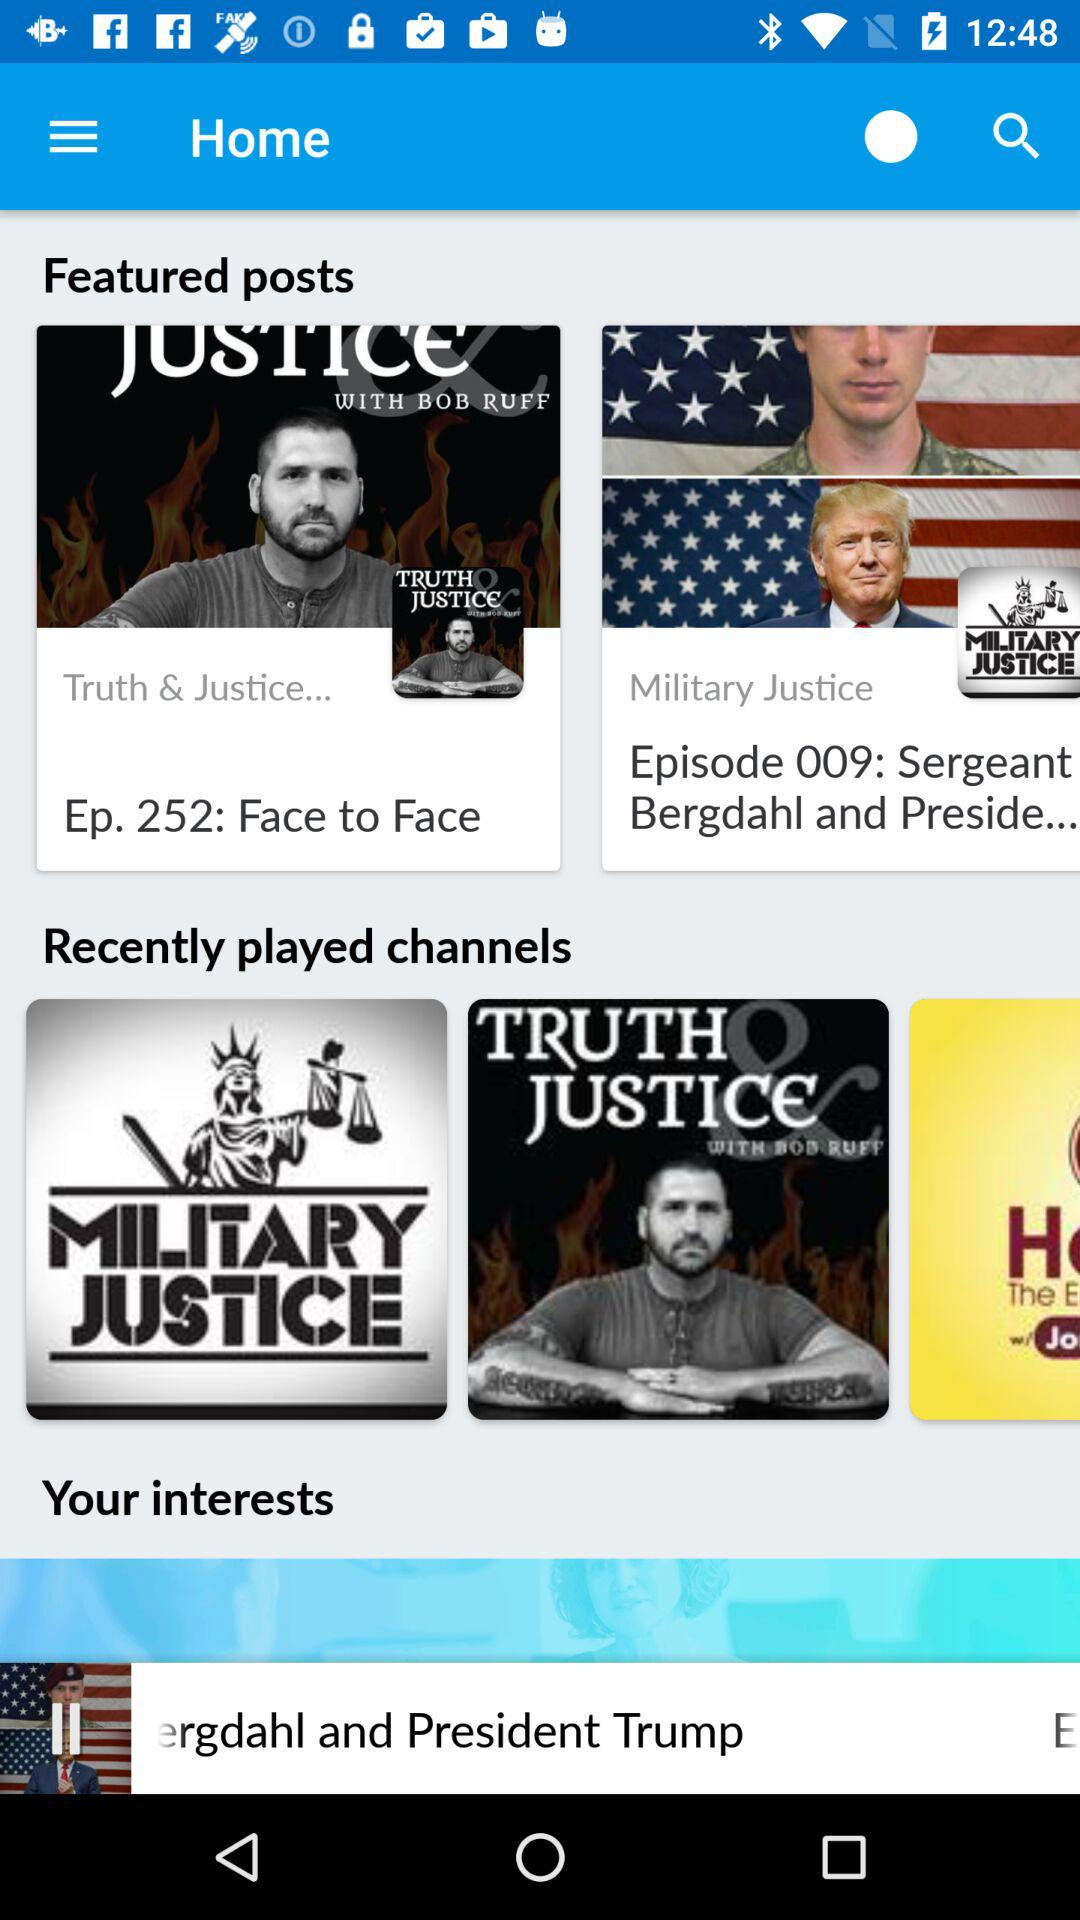What are the recently played channels? The recently played channels are "MILITARY JUSTICE" and "TRUTH JUSTICE". 